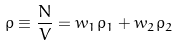Convert formula to latex. <formula><loc_0><loc_0><loc_500><loc_500>\rho \equiv \frac { N } { V } = w _ { 1 } \rho _ { 1 } + w _ { 2 } \rho _ { 2 }</formula> 